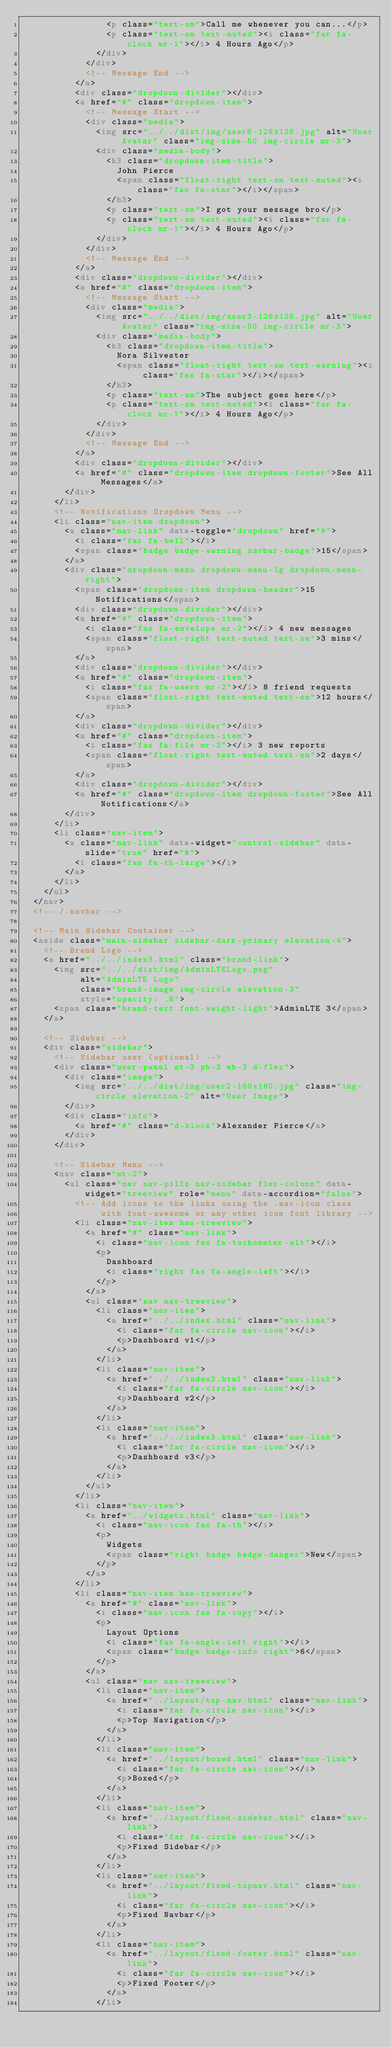Convert code to text. <code><loc_0><loc_0><loc_500><loc_500><_HTML_>                <p class="text-sm">Call me whenever you can...</p>
                <p class="text-sm text-muted"><i class="far fa-clock mr-1"></i> 4 Hours Ago</p>
              </div>
            </div>
            <!-- Message End -->
          </a>
          <div class="dropdown-divider"></div>
          <a href="#" class="dropdown-item">
            <!-- Message Start -->
            <div class="media">
              <img src="../../dist/img/user8-128x128.jpg" alt="User Avatar" class="img-size-50 img-circle mr-3">
              <div class="media-body">
                <h3 class="dropdown-item-title">
                  John Pierce
                  <span class="float-right text-sm text-muted"><i class="fas fa-star"></i></span>
                </h3>
                <p class="text-sm">I got your message bro</p>
                <p class="text-sm text-muted"><i class="far fa-clock mr-1"></i> 4 Hours Ago</p>
              </div>
            </div>
            <!-- Message End -->
          </a>
          <div class="dropdown-divider"></div>
          <a href="#" class="dropdown-item">
            <!-- Message Start -->
            <div class="media">
              <img src="../../dist/img/user3-128x128.jpg" alt="User Avatar" class="img-size-50 img-circle mr-3">
              <div class="media-body">
                <h3 class="dropdown-item-title">
                  Nora Silvester
                  <span class="float-right text-sm text-warning"><i class="fas fa-star"></i></span>
                </h3>
                <p class="text-sm">The subject goes here</p>
                <p class="text-sm text-muted"><i class="far fa-clock mr-1"></i> 4 Hours Ago</p>
              </div>
            </div>
            <!-- Message End -->
          </a>
          <div class="dropdown-divider"></div>
          <a href="#" class="dropdown-item dropdown-footer">See All Messages</a>
        </div>
      </li>
      <!-- Notifications Dropdown Menu -->
      <li class="nav-item dropdown">
        <a class="nav-link" data-toggle="dropdown" href="#">
          <i class="far fa-bell"></i>
          <span class="badge badge-warning navbar-badge">15</span>
        </a>
        <div class="dropdown-menu dropdown-menu-lg dropdown-menu-right">
          <span class="dropdown-item dropdown-header">15 Notifications</span>
          <div class="dropdown-divider"></div>
          <a href="#" class="dropdown-item">
            <i class="fas fa-envelope mr-2"></i> 4 new messages
            <span class="float-right text-muted text-sm">3 mins</span>
          </a>
          <div class="dropdown-divider"></div>
          <a href="#" class="dropdown-item">
            <i class="fas fa-users mr-2"></i> 8 friend requests
            <span class="float-right text-muted text-sm">12 hours</span>
          </a>
          <div class="dropdown-divider"></div>
          <a href="#" class="dropdown-item">
            <i class="fas fa-file mr-2"></i> 3 new reports
            <span class="float-right text-muted text-sm">2 days</span>
          </a>
          <div class="dropdown-divider"></div>
          <a href="#" class="dropdown-item dropdown-footer">See All Notifications</a>
        </div>
      </li>
      <li class="nav-item">
        <a class="nav-link" data-widget="control-sidebar" data-slide="true" href="#">
          <i class="fas fa-th-large"></i>
        </a>
      </li>
    </ul>
  </nav>
  <!-- /.navbar -->

  <!-- Main Sidebar Container -->
  <aside class="main-sidebar sidebar-dark-primary elevation-4">
    <!-- Brand Logo -->
    <a href="../../index3.html" class="brand-link">
      <img src="../../dist/img/AdminLTELogo.png"
           alt="AdminLTE Logo"
           class="brand-image img-circle elevation-3"
           style="opacity: .8">
      <span class="brand-text font-weight-light">AdminLTE 3</span>
    </a>

    <!-- Sidebar -->
    <div class="sidebar">
      <!-- Sidebar user (optional) -->
      <div class="user-panel mt-3 pb-3 mb-3 d-flex">
        <div class="image">
          <img src="../../dist/img/user2-160x160.jpg" class="img-circle elevation-2" alt="User Image">
        </div>
        <div class="info">
          <a href="#" class="d-block">Alexander Pierce</a>
        </div>
      </div>

      <!-- Sidebar Menu -->
      <nav class="mt-2">
        <ul class="nav nav-pills nav-sidebar flex-column" data-widget="treeview" role="menu" data-accordion="false">
          <!-- Add icons to the links using the .nav-icon class
               with font-awesome or any other icon font library -->
          <li class="nav-item has-treeview">
            <a href="#" class="nav-link">
              <i class="nav-icon fas fa-tachometer-alt"></i>
              <p>
                Dashboard
                <i class="right fas fa-angle-left"></i>
              </p>
            </a>
            <ul class="nav nav-treeview">
              <li class="nav-item">
                <a href="../../index.html" class="nav-link">
                  <i class="far fa-circle nav-icon"></i>
                  <p>Dashboard v1</p>
                </a>
              </li>
              <li class="nav-item">
                <a href="../../index2.html" class="nav-link">
                  <i class="far fa-circle nav-icon"></i>
                  <p>Dashboard v2</p>
                </a>
              </li>
              <li class="nav-item">
                <a href="../../index3.html" class="nav-link">
                  <i class="far fa-circle nav-icon"></i>
                  <p>Dashboard v3</p>
                </a>
              </li>
            </ul>
          </li>
          <li class="nav-item">
            <a href="../widgets.html" class="nav-link">
              <i class="nav-icon fas fa-th"></i>
              <p>
                Widgets
                <span class="right badge badge-danger">New</span>
              </p>
            </a>
          </li>
          <li class="nav-item has-treeview">
            <a href="#" class="nav-link">
              <i class="nav-icon fas fa-copy"></i>
              <p>
                Layout Options
                <i class="fas fa-angle-left right"></i>
                <span class="badge badge-info right">6</span>
              </p>
            </a>
            <ul class="nav nav-treeview">
              <li class="nav-item">
                <a href="../layout/top-nav.html" class="nav-link">
                  <i class="far fa-circle nav-icon"></i>
                  <p>Top Navigation</p>
                </a>
              </li>
              <li class="nav-item">
                <a href="../layout/boxed.html" class="nav-link">
                  <i class="far fa-circle nav-icon"></i>
                  <p>Boxed</p>
                </a>
              </li>
              <li class="nav-item">
                <a href="../layout/fixed-sidebar.html" class="nav-link">
                  <i class="far fa-circle nav-icon"></i>
                  <p>Fixed Sidebar</p>
                </a>
              </li>
              <li class="nav-item">
                <a href="../layout/fixed-topnav.html" class="nav-link">
                  <i class="far fa-circle nav-icon"></i>
                  <p>Fixed Navbar</p>
                </a>
              </li>
              <li class="nav-item">
                <a href="../layout/fixed-footer.html" class="nav-link">
                  <i class="far fa-circle nav-icon"></i>
                  <p>Fixed Footer</p>
                </a>
              </li></code> 